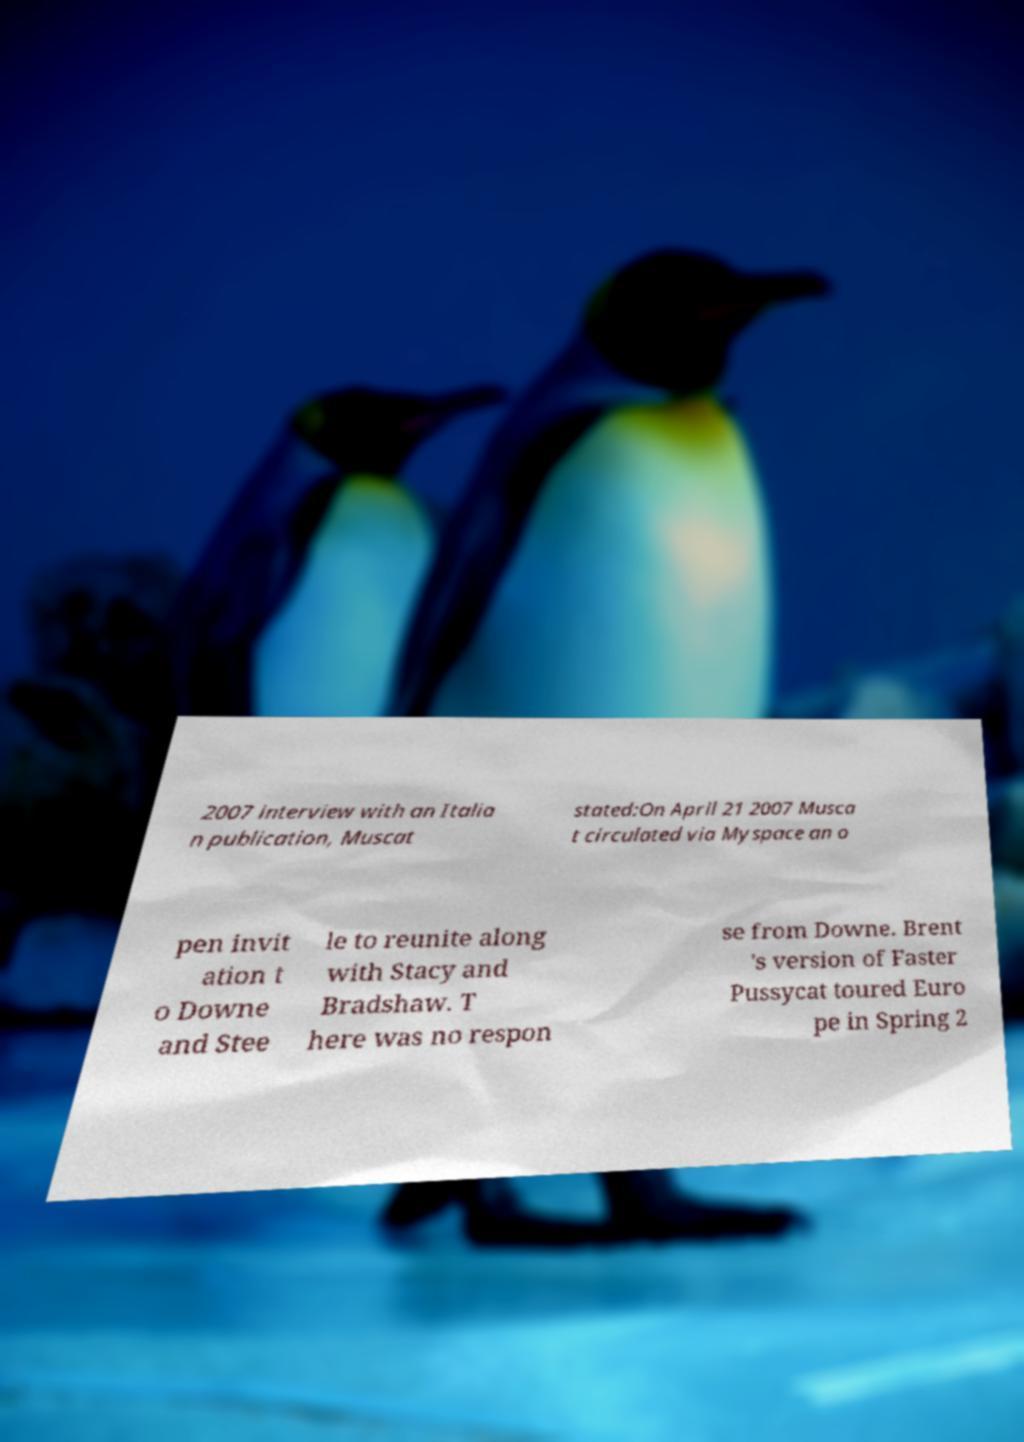Could you extract and type out the text from this image? 2007 interview with an Italia n publication, Muscat stated:On April 21 2007 Musca t circulated via Myspace an o pen invit ation t o Downe and Stee le to reunite along with Stacy and Bradshaw. T here was no respon se from Downe. Brent 's version of Faster Pussycat toured Euro pe in Spring 2 